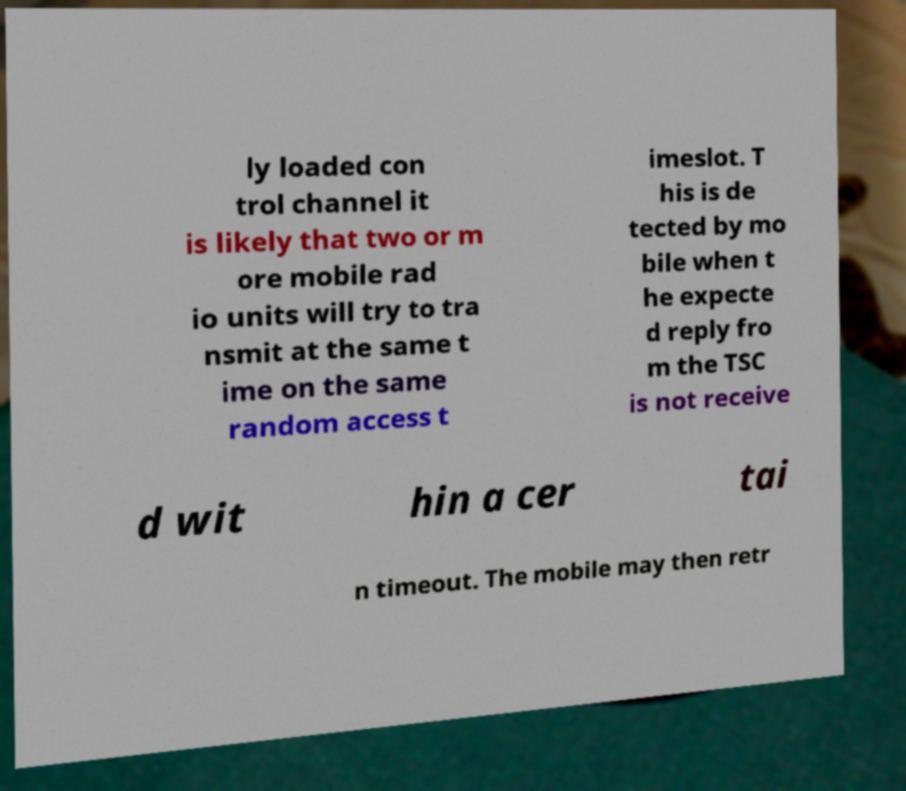Can you accurately transcribe the text from the provided image for me? ly loaded con trol channel it is likely that two or m ore mobile rad io units will try to tra nsmit at the same t ime on the same random access t imeslot. T his is de tected by mo bile when t he expecte d reply fro m the TSC is not receive d wit hin a cer tai n timeout. The mobile may then retr 